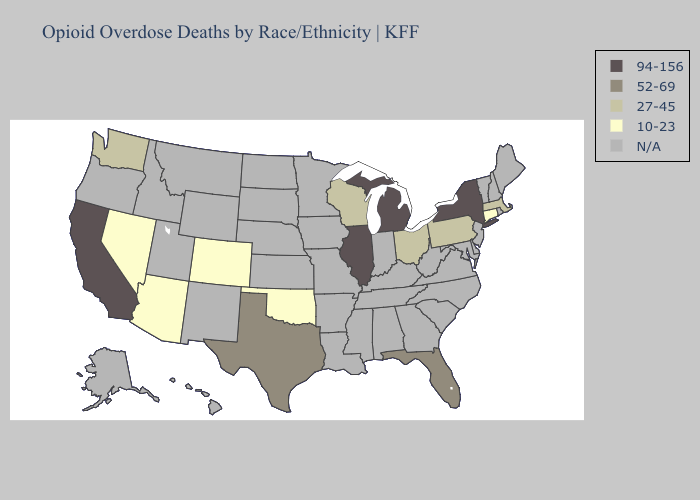Does Florida have the lowest value in the South?
Quick response, please. No. Name the states that have a value in the range 94-156?
Write a very short answer. California, Illinois, Michigan, New York. Name the states that have a value in the range 52-69?
Short answer required. Florida, Texas. What is the value of Arizona?
Write a very short answer. 10-23. Name the states that have a value in the range 10-23?
Give a very brief answer. Arizona, Colorado, Connecticut, Nevada, Oklahoma. What is the value of Maine?
Give a very brief answer. N/A. Does Oklahoma have the lowest value in the South?
Be succinct. Yes. What is the value of Delaware?
Short answer required. N/A. What is the value of Maine?
Write a very short answer. N/A. Name the states that have a value in the range 27-45?
Short answer required. Massachusetts, Ohio, Pennsylvania, Washington, Wisconsin. Among the states that border Ohio , does Michigan have the lowest value?
Be succinct. No. Does Connecticut have the highest value in the Northeast?
Be succinct. No. 